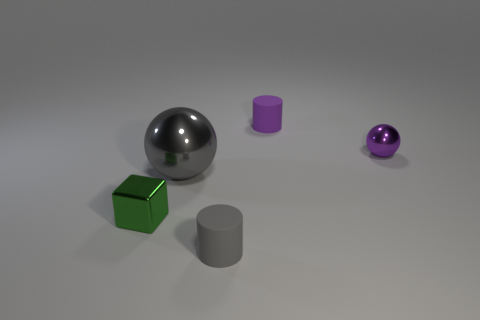How would you describe the surface the objects are on? The surface appears to be a flat, uniform, and smooth plane with a neutral color. It reflects light mildly, hinting at a matte or semi-matte texture. The absence of any distinct features or texture gives the composition a clean and minimalist aesthetic. 